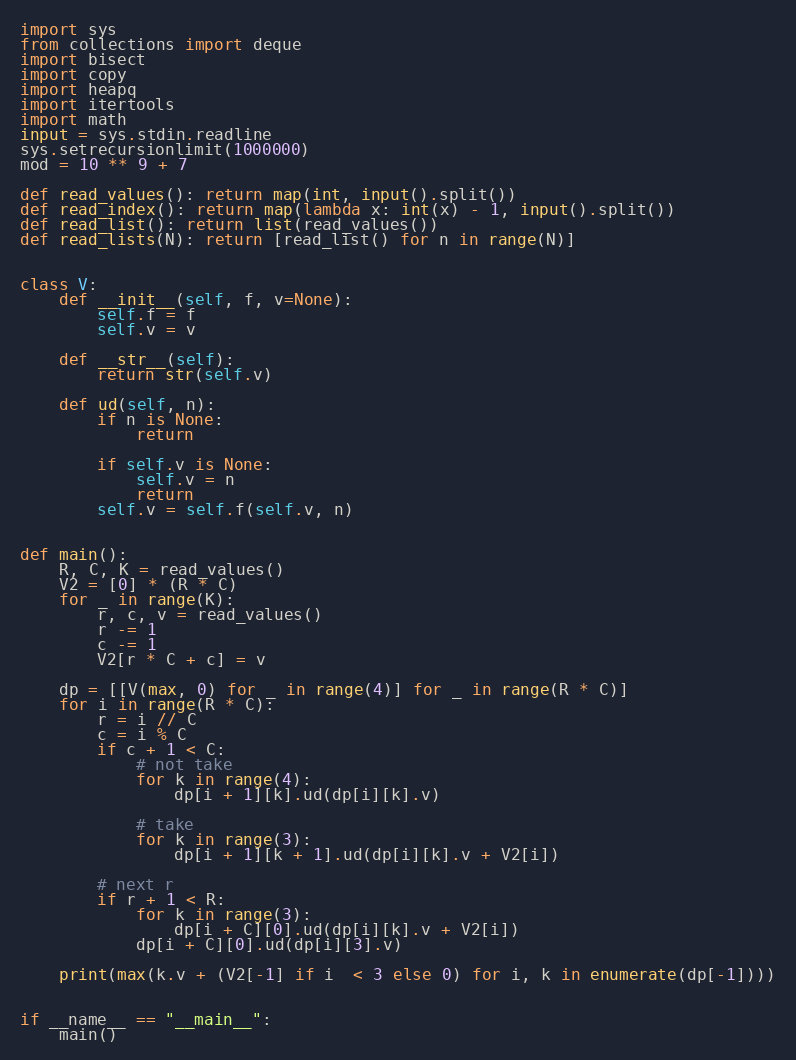Convert code to text. <code><loc_0><loc_0><loc_500><loc_500><_Python_>import sys
from collections import deque
import bisect
import copy
import heapq
import itertools
import math
input = sys.stdin.readline
sys.setrecursionlimit(1000000)
mod = 10 ** 9 + 7

def read_values(): return map(int, input().split())
def read_index(): return map(lambda x: int(x) - 1, input().split())
def read_list(): return list(read_values())
def read_lists(N): return [read_list() for n in range(N)]


class V:
    def __init__(self, f, v=None):
        self.f = f
        self.v = v
 
    def __str__(self):
        return str(self.v)
 
    def ud(self, n):
        if n is None:
            return

        if self.v is None:
            self.v = n
            return
        self.v = self.f(self.v, n) 


def main():
    R, C, K = read_values()
    V2 = [0] * (R * C)
    for _ in range(K):
        r, c, v = read_values()
        r -= 1
        c -= 1
        V2[r * C + c] = v
    
    dp = [[V(max, 0) for _ in range(4)] for _ in range(R * C)]
    for i in range(R * C):
        r = i // C
        c = i % C
        if c + 1 < C:
            # not take
            for k in range(4):
                dp[i + 1][k].ud(dp[i][k].v)

            # take 
            for k in range(3):
                dp[i + 1][k + 1].ud(dp[i][k].v + V2[i])

        # next r
        if r + 1 < R:
            for k in range(3):
                dp[i + C][0].ud(dp[i][k].v + V2[i])
            dp[i + C][0].ud(dp[i][3].v)

    print(max(k.v + (V2[-1] if i  < 3 else 0) for i, k in enumerate(dp[-1])))


if __name__ == "__main__":
    main()

</code> 